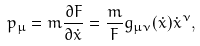Convert formula to latex. <formula><loc_0><loc_0><loc_500><loc_500>p _ { \mu } = m \frac { \partial F } { \partial \dot { x } } = \frac { m } { F } g _ { \mu \nu } ( \dot { x } ) \dot { x } ^ { \nu } ,</formula> 